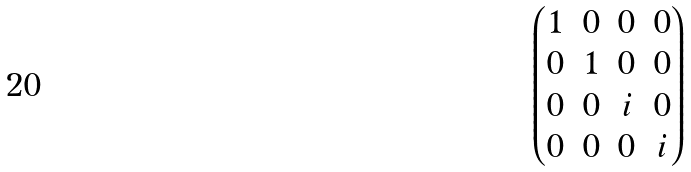<formula> <loc_0><loc_0><loc_500><loc_500>\begin{pmatrix} 1 & 0 & 0 & 0 \\ 0 & 1 & 0 & 0 \\ 0 & 0 & i & 0 \\ 0 & 0 & 0 & i \end{pmatrix}</formula> 